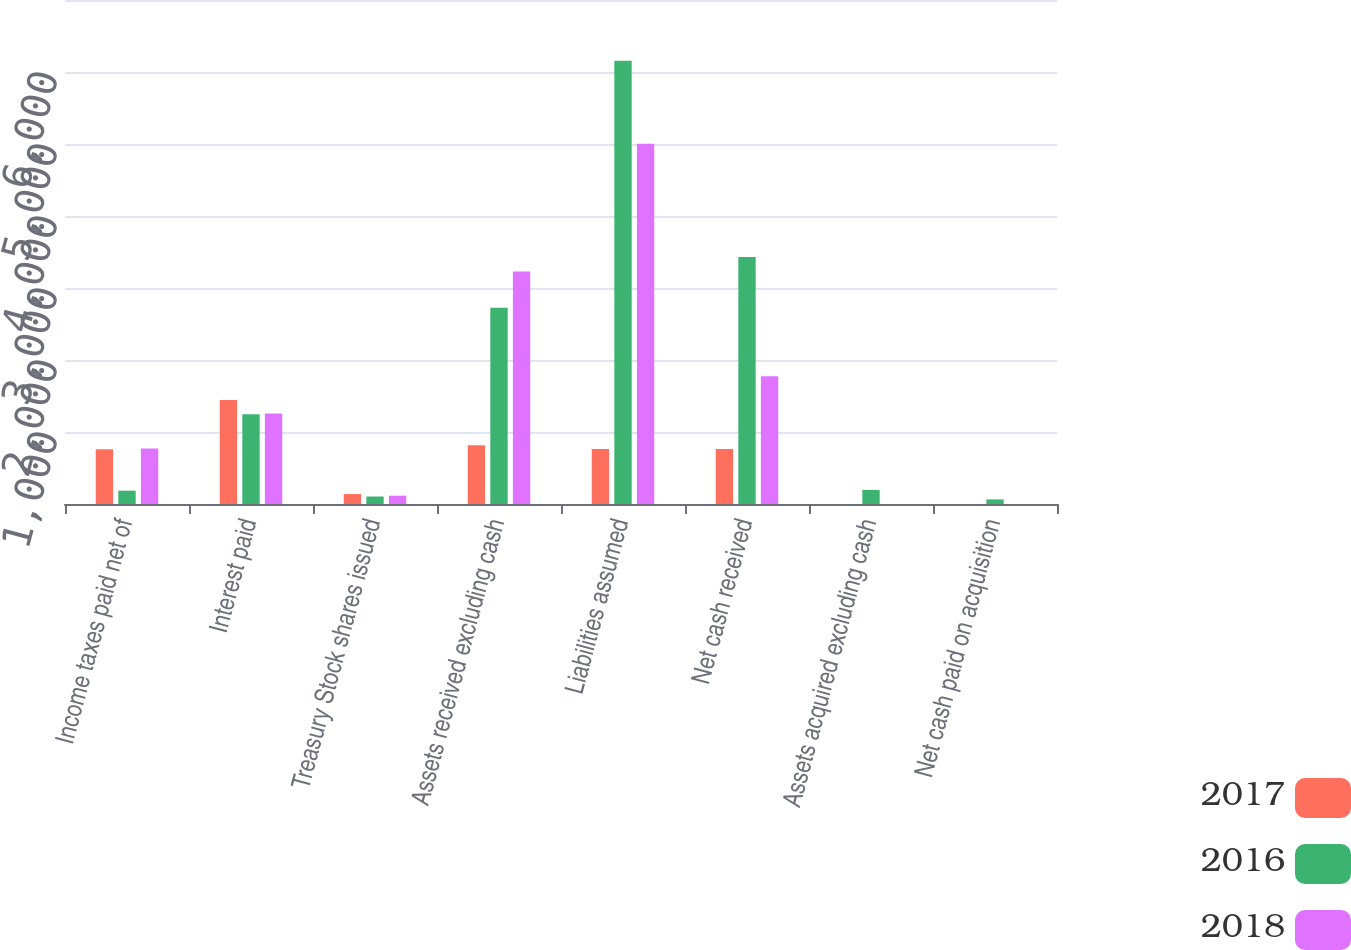<chart> <loc_0><loc_0><loc_500><loc_500><stacked_bar_chart><ecel><fcel>Income taxes paid net of<fcel>Interest paid<fcel>Treasury Stock shares issued<fcel>Assets received excluding cash<fcel>Liabilities assumed<fcel>Net cash received<fcel>Assets acquired excluding cash<fcel>Net cash paid on acquisition<nl><fcel>2017<fcel>760<fcel>1443<fcel>138<fcel>816<fcel>765<fcel>765<fcel>0<fcel>0<nl><fcel>2016<fcel>185<fcel>1248<fcel>104<fcel>2726<fcel>6155<fcel>3429<fcel>196<fcel>64<nl><fcel>2018<fcel>770<fcel>1257<fcel>115<fcel>3228<fcel>5003<fcel>1775<fcel>0<fcel>0<nl></chart> 